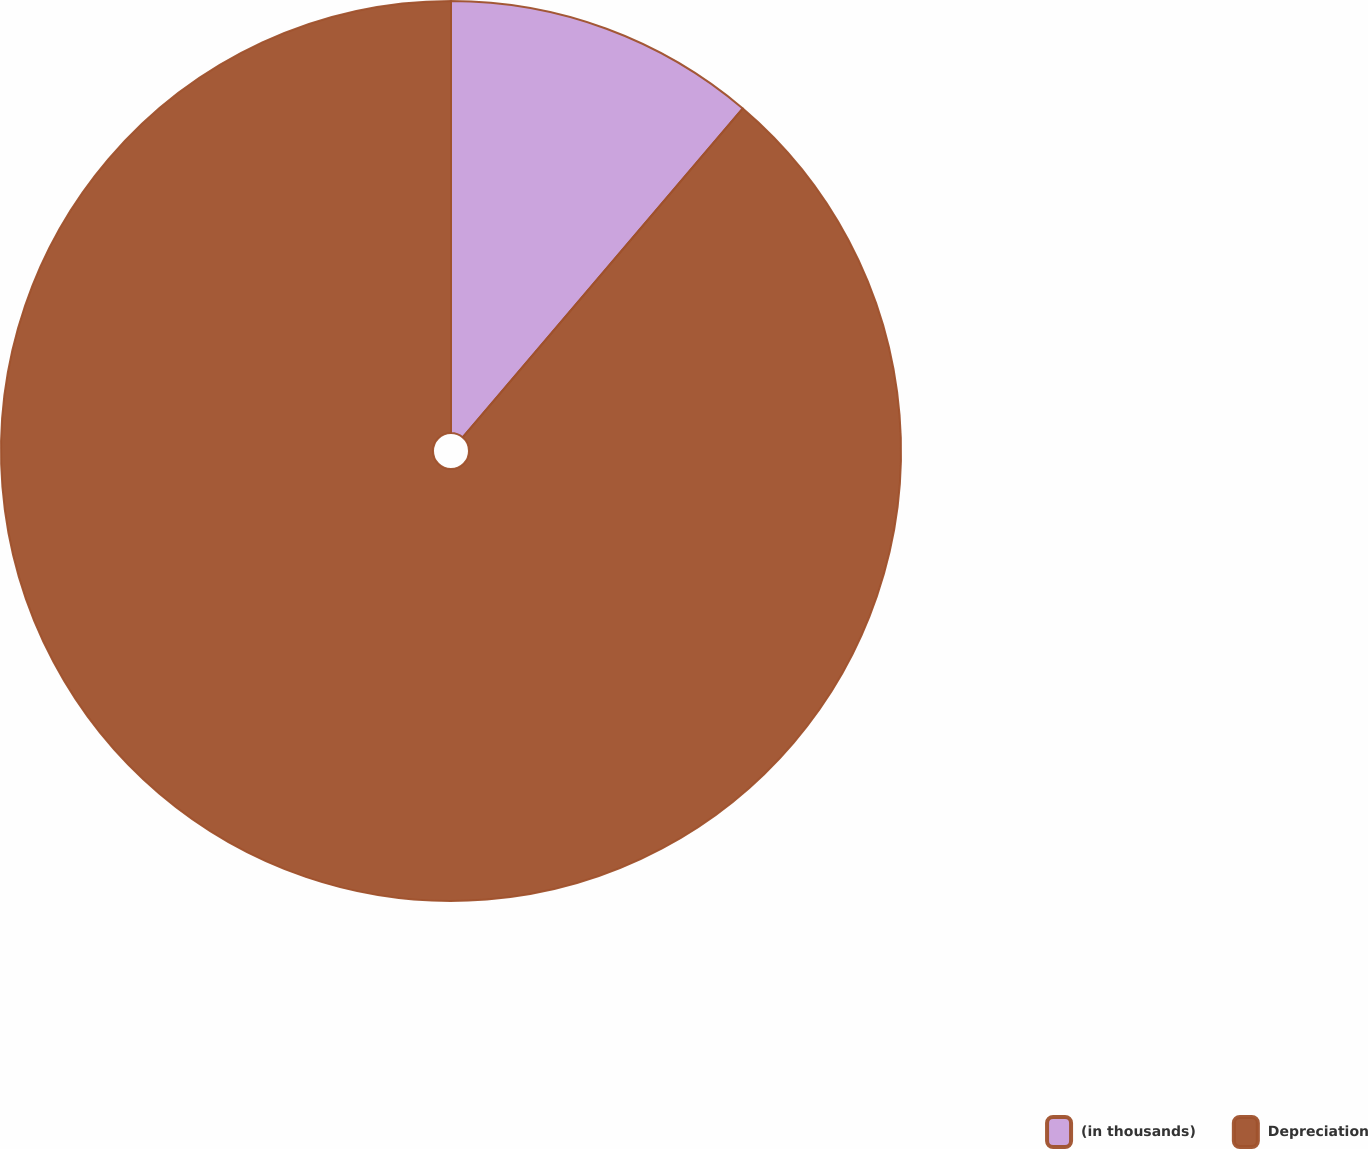Convert chart. <chart><loc_0><loc_0><loc_500><loc_500><pie_chart><fcel>(in thousands)<fcel>Depreciation<nl><fcel>11.23%<fcel>88.77%<nl></chart> 